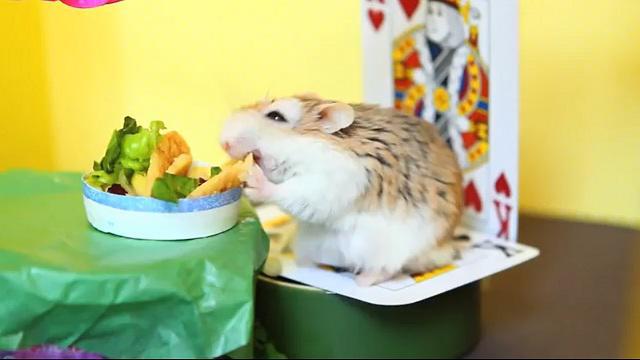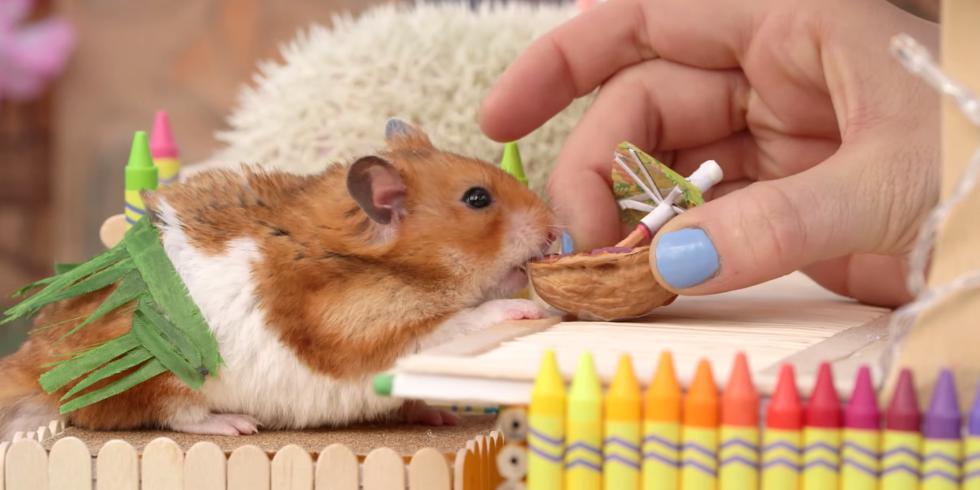The first image is the image on the left, the second image is the image on the right. Given the left and right images, does the statement "One image shows a hamster in a chair dining at a kind of table and wearing a costume hat." hold true? Answer yes or no. No. The first image is the image on the left, the second image is the image on the right. Assess this claim about the two images: "An image contains a rodent wearing a small hat.". Correct or not? Answer yes or no. No. 